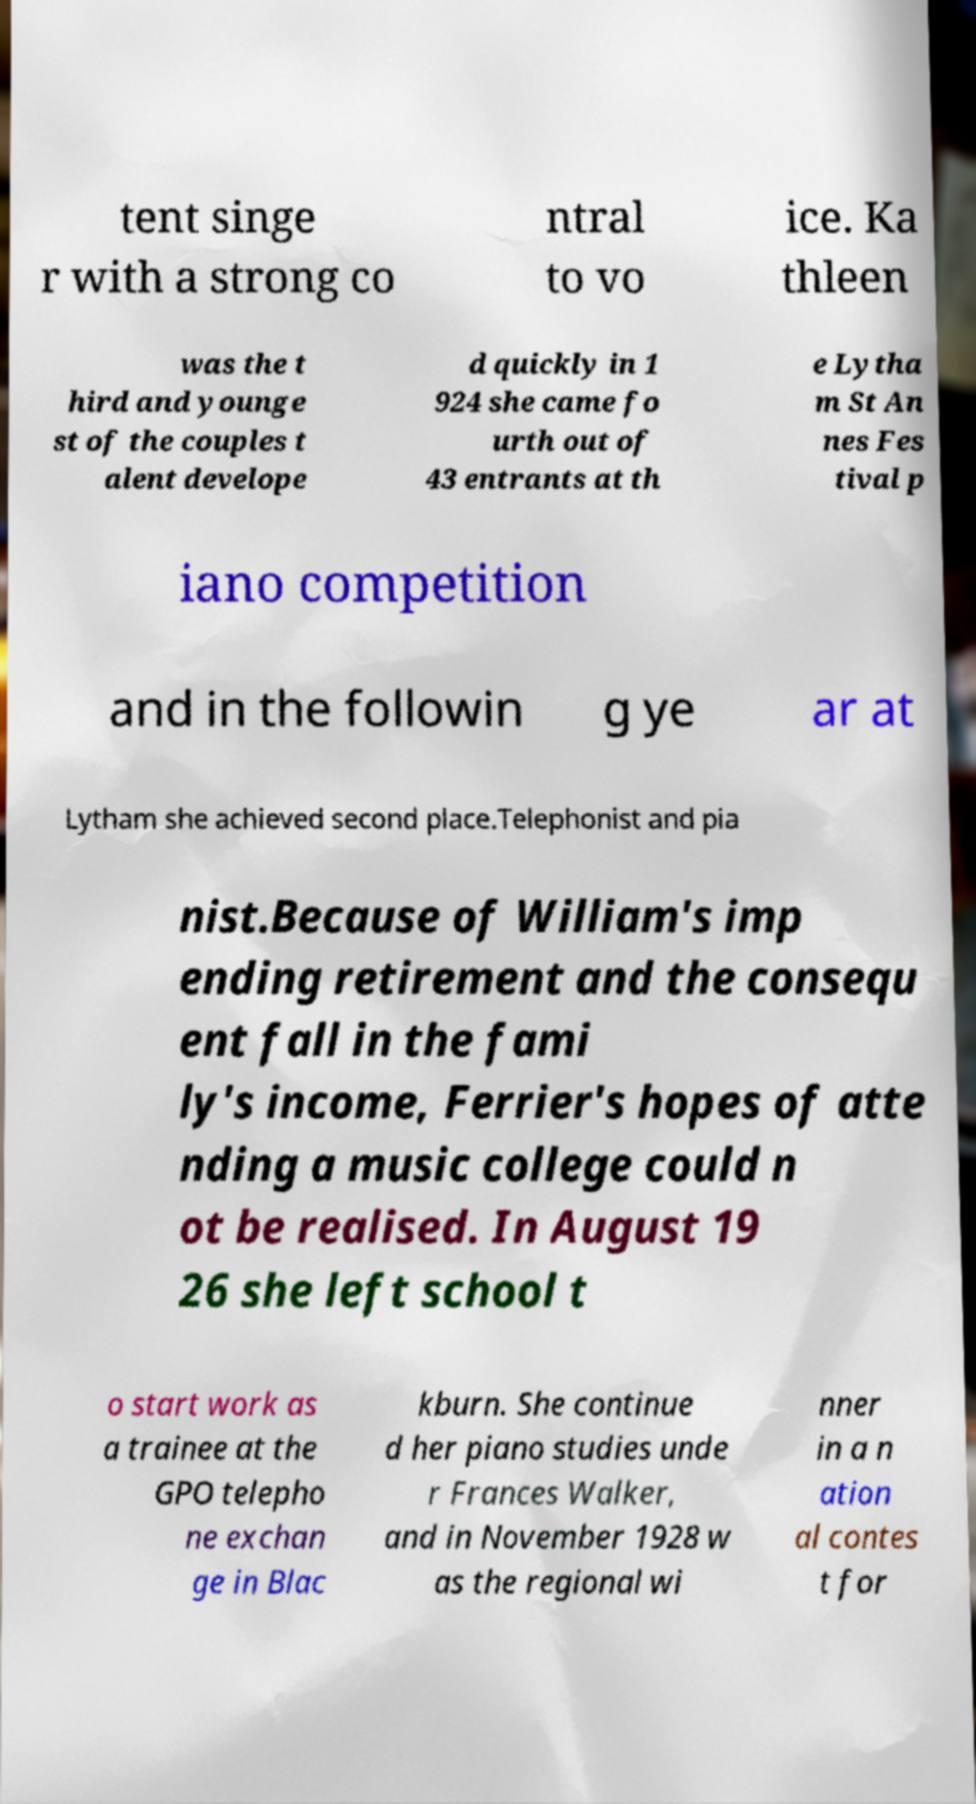Please identify and transcribe the text found in this image. tent singe r with a strong co ntral to vo ice. Ka thleen was the t hird and younge st of the couples t alent develope d quickly in 1 924 she came fo urth out of 43 entrants at th e Lytha m St An nes Fes tival p iano competition and in the followin g ye ar at Lytham she achieved second place.Telephonist and pia nist.Because of William's imp ending retirement and the consequ ent fall in the fami ly's income, Ferrier's hopes of atte nding a music college could n ot be realised. In August 19 26 she left school t o start work as a trainee at the GPO telepho ne exchan ge in Blac kburn. She continue d her piano studies unde r Frances Walker, and in November 1928 w as the regional wi nner in a n ation al contes t for 